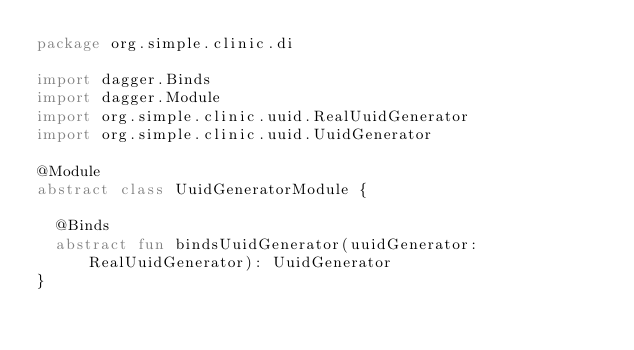Convert code to text. <code><loc_0><loc_0><loc_500><loc_500><_Kotlin_>package org.simple.clinic.di

import dagger.Binds
import dagger.Module
import org.simple.clinic.uuid.RealUuidGenerator
import org.simple.clinic.uuid.UuidGenerator

@Module
abstract class UuidGeneratorModule {

  @Binds
  abstract fun bindsUuidGenerator(uuidGenerator: RealUuidGenerator): UuidGenerator
}
</code> 